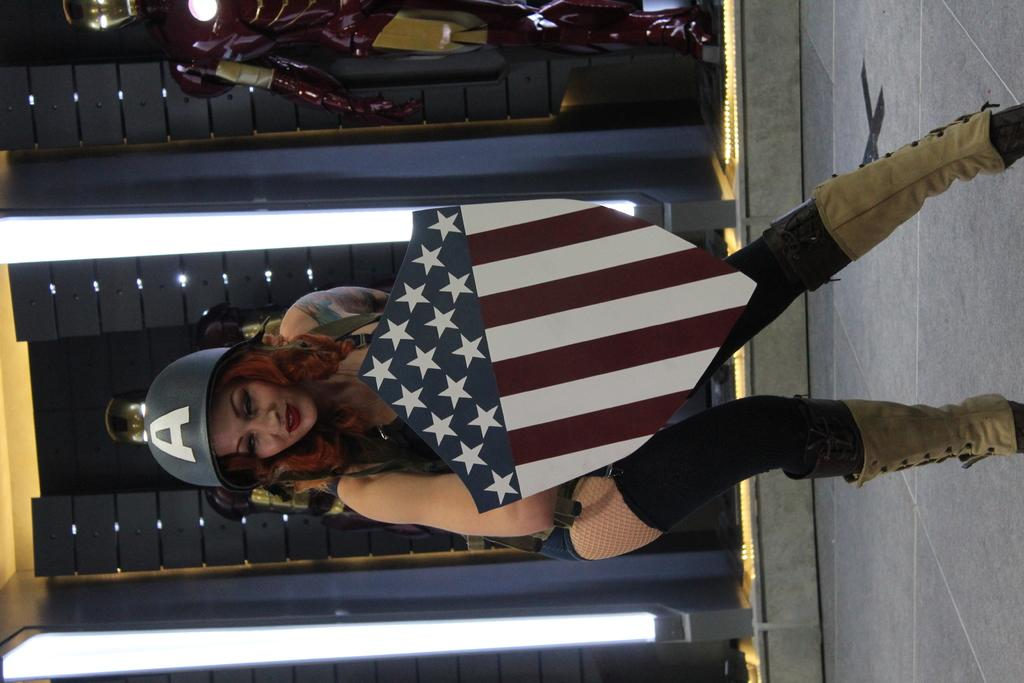Who is the main subject in the image? There is a lady in the image. What is the lady holding in the image? The lady is holding a board. What type of headwear is the lady wearing? The lady is wearing a hat. What can be seen in the background of the image? There is a wall and lights in the background of the image. What other object is present in the image? There is a robot in the image. What type of poison is the lady using to trick her parent in the image? There is no mention of poison, trickery, or parents in the image; it features a lady holding a board, wearing a hat, and standing near a wall with lights and a robot. 